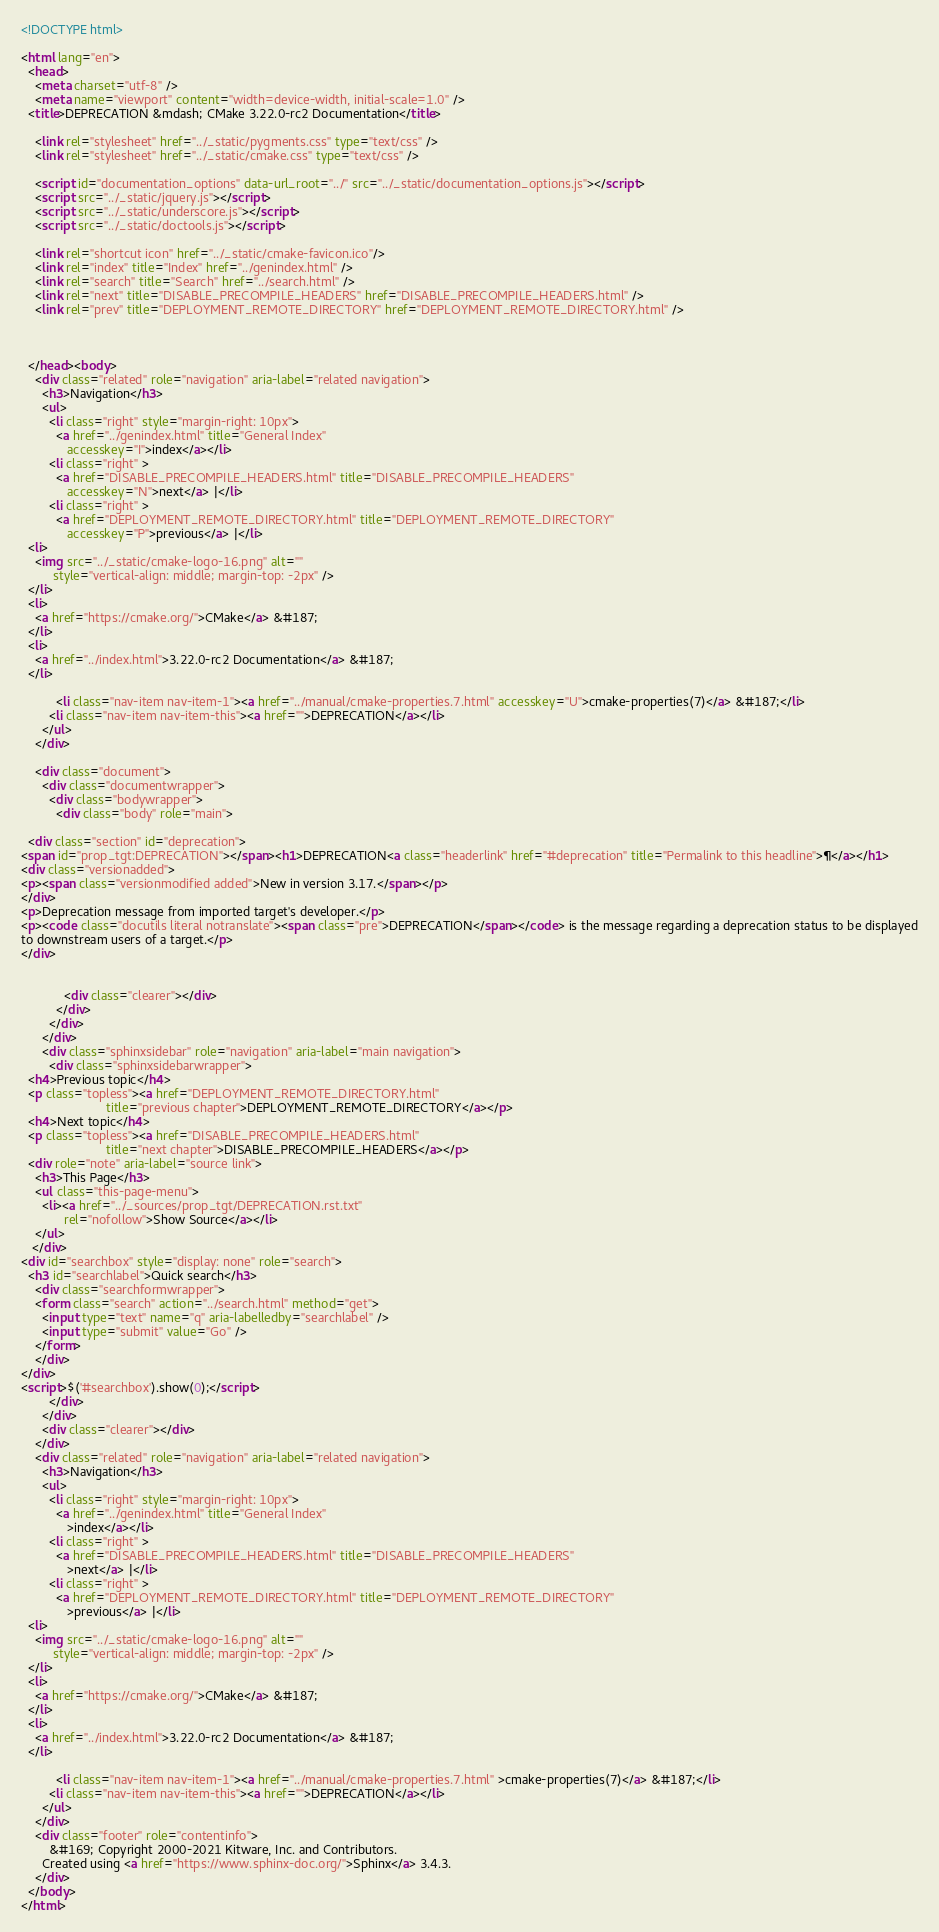Convert code to text. <code><loc_0><loc_0><loc_500><loc_500><_HTML_>
<!DOCTYPE html>

<html lang="en">
  <head>
    <meta charset="utf-8" />
    <meta name="viewport" content="width=device-width, initial-scale=1.0" />
  <title>DEPRECATION &mdash; CMake 3.22.0-rc2 Documentation</title>

    <link rel="stylesheet" href="../_static/pygments.css" type="text/css" />
    <link rel="stylesheet" href="../_static/cmake.css" type="text/css" />
    
    <script id="documentation_options" data-url_root="../" src="../_static/documentation_options.js"></script>
    <script src="../_static/jquery.js"></script>
    <script src="../_static/underscore.js"></script>
    <script src="../_static/doctools.js"></script>
    
    <link rel="shortcut icon" href="../_static/cmake-favicon.ico"/>
    <link rel="index" title="Index" href="../genindex.html" />
    <link rel="search" title="Search" href="../search.html" />
    <link rel="next" title="DISABLE_PRECOMPILE_HEADERS" href="DISABLE_PRECOMPILE_HEADERS.html" />
    <link rel="prev" title="DEPLOYMENT_REMOTE_DIRECTORY" href="DEPLOYMENT_REMOTE_DIRECTORY.html" />
  
 

  </head><body>
    <div class="related" role="navigation" aria-label="related navigation">
      <h3>Navigation</h3>
      <ul>
        <li class="right" style="margin-right: 10px">
          <a href="../genindex.html" title="General Index"
             accesskey="I">index</a></li>
        <li class="right" >
          <a href="DISABLE_PRECOMPILE_HEADERS.html" title="DISABLE_PRECOMPILE_HEADERS"
             accesskey="N">next</a> |</li>
        <li class="right" >
          <a href="DEPLOYMENT_REMOTE_DIRECTORY.html" title="DEPLOYMENT_REMOTE_DIRECTORY"
             accesskey="P">previous</a> |</li>
  <li>
    <img src="../_static/cmake-logo-16.png" alt=""
         style="vertical-align: middle; margin-top: -2px" />
  </li>
  <li>
    <a href="https://cmake.org/">CMake</a> &#187;
  </li>
  <li>
    <a href="../index.html">3.22.0-rc2 Documentation</a> &#187;
  </li>

          <li class="nav-item nav-item-1"><a href="../manual/cmake-properties.7.html" accesskey="U">cmake-properties(7)</a> &#187;</li>
        <li class="nav-item nav-item-this"><a href="">DEPRECATION</a></li> 
      </ul>
    </div>  

    <div class="document">
      <div class="documentwrapper">
        <div class="bodywrapper">
          <div class="body" role="main">
            
  <div class="section" id="deprecation">
<span id="prop_tgt:DEPRECATION"></span><h1>DEPRECATION<a class="headerlink" href="#deprecation" title="Permalink to this headline">¶</a></h1>
<div class="versionadded">
<p><span class="versionmodified added">New in version 3.17.</span></p>
</div>
<p>Deprecation message from imported target's developer.</p>
<p><code class="docutils literal notranslate"><span class="pre">DEPRECATION</span></code> is the message regarding a deprecation status to be displayed
to downstream users of a target.</p>
</div>


            <div class="clearer"></div>
          </div>
        </div>
      </div>
      <div class="sphinxsidebar" role="navigation" aria-label="main navigation">
        <div class="sphinxsidebarwrapper">
  <h4>Previous topic</h4>
  <p class="topless"><a href="DEPLOYMENT_REMOTE_DIRECTORY.html"
                        title="previous chapter">DEPLOYMENT_REMOTE_DIRECTORY</a></p>
  <h4>Next topic</h4>
  <p class="topless"><a href="DISABLE_PRECOMPILE_HEADERS.html"
                        title="next chapter">DISABLE_PRECOMPILE_HEADERS</a></p>
  <div role="note" aria-label="source link">
    <h3>This Page</h3>
    <ul class="this-page-menu">
      <li><a href="../_sources/prop_tgt/DEPRECATION.rst.txt"
            rel="nofollow">Show Source</a></li>
    </ul>
   </div>
<div id="searchbox" style="display: none" role="search">
  <h3 id="searchlabel">Quick search</h3>
    <div class="searchformwrapper">
    <form class="search" action="../search.html" method="get">
      <input type="text" name="q" aria-labelledby="searchlabel" />
      <input type="submit" value="Go" />
    </form>
    </div>
</div>
<script>$('#searchbox').show(0);</script>
        </div>
      </div>
      <div class="clearer"></div>
    </div>
    <div class="related" role="navigation" aria-label="related navigation">
      <h3>Navigation</h3>
      <ul>
        <li class="right" style="margin-right: 10px">
          <a href="../genindex.html" title="General Index"
             >index</a></li>
        <li class="right" >
          <a href="DISABLE_PRECOMPILE_HEADERS.html" title="DISABLE_PRECOMPILE_HEADERS"
             >next</a> |</li>
        <li class="right" >
          <a href="DEPLOYMENT_REMOTE_DIRECTORY.html" title="DEPLOYMENT_REMOTE_DIRECTORY"
             >previous</a> |</li>
  <li>
    <img src="../_static/cmake-logo-16.png" alt=""
         style="vertical-align: middle; margin-top: -2px" />
  </li>
  <li>
    <a href="https://cmake.org/">CMake</a> &#187;
  </li>
  <li>
    <a href="../index.html">3.22.0-rc2 Documentation</a> &#187;
  </li>

          <li class="nav-item nav-item-1"><a href="../manual/cmake-properties.7.html" >cmake-properties(7)</a> &#187;</li>
        <li class="nav-item nav-item-this"><a href="">DEPRECATION</a></li> 
      </ul>
    </div>
    <div class="footer" role="contentinfo">
        &#169; Copyright 2000-2021 Kitware, Inc. and Contributors.
      Created using <a href="https://www.sphinx-doc.org/">Sphinx</a> 3.4.3.
    </div>
  </body>
</html></code> 